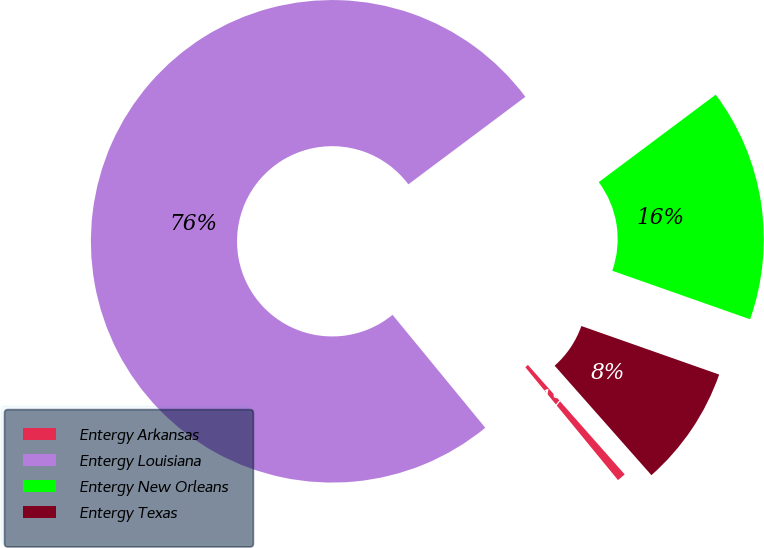Convert chart to OTSL. <chart><loc_0><loc_0><loc_500><loc_500><pie_chart><fcel>Entergy Arkansas<fcel>Entergy Louisiana<fcel>Entergy New Orleans<fcel>Entergy Texas<nl><fcel>0.58%<fcel>75.73%<fcel>15.61%<fcel>8.09%<nl></chart> 